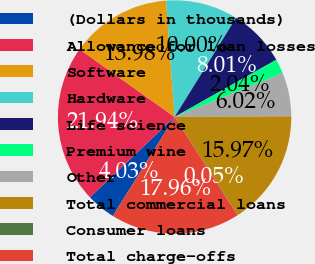<chart> <loc_0><loc_0><loc_500><loc_500><pie_chart><fcel>(Dollars in thousands)<fcel>Allowance for loan losses<fcel>Software<fcel>Hardware<fcel>Life science<fcel>Premium wine<fcel>Other<fcel>Total commercial loans<fcel>Consumer loans<fcel>Total charge-offs<nl><fcel>4.03%<fcel>21.94%<fcel>13.98%<fcel>10.0%<fcel>8.01%<fcel>2.04%<fcel>6.02%<fcel>15.97%<fcel>0.05%<fcel>17.96%<nl></chart> 